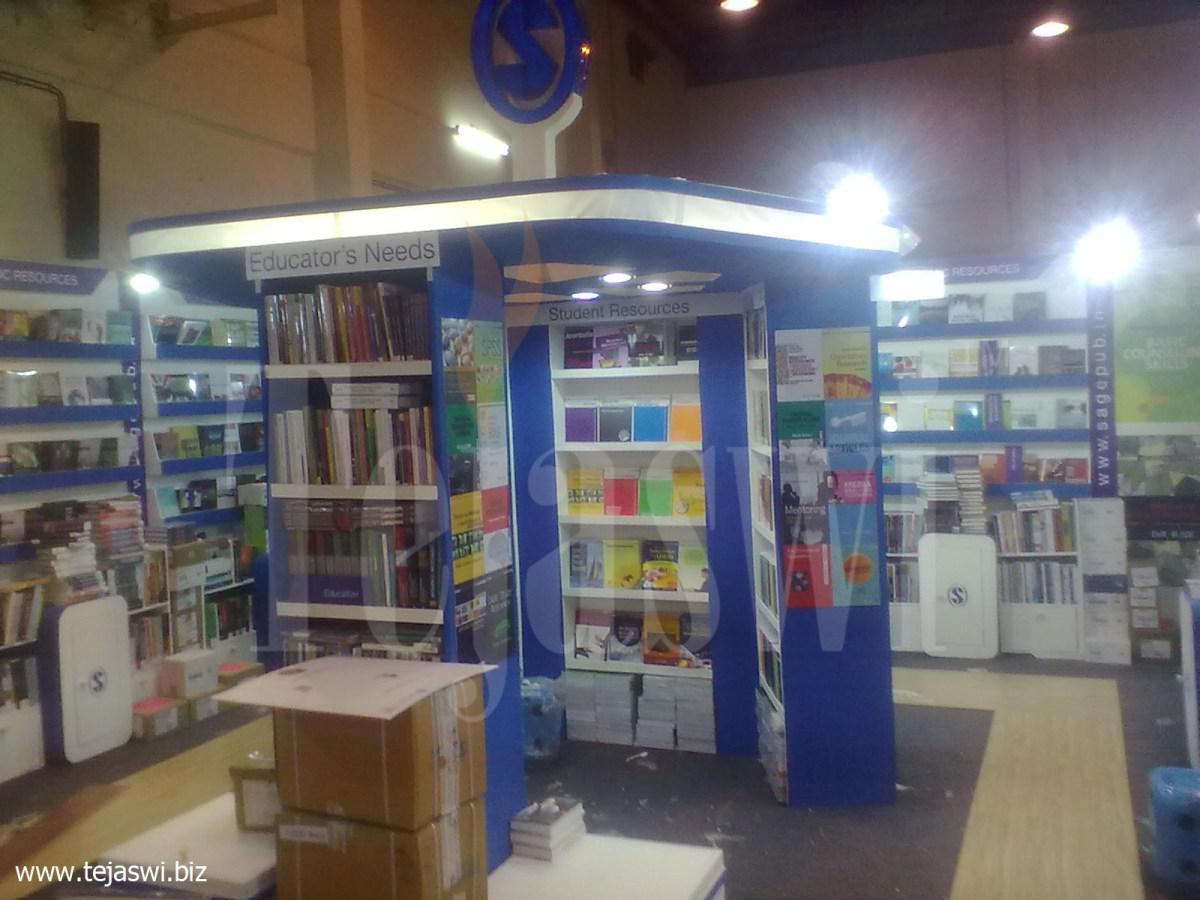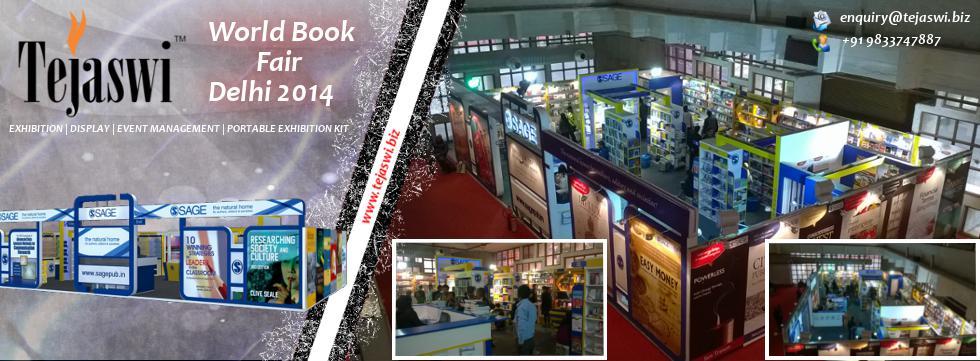The first image is the image on the left, the second image is the image on the right. Considering the images on both sides, is "The left image includes a standing blue display with an S shape in a circle somewhere above it." valid? Answer yes or no. Yes. The first image is the image on the left, the second image is the image on the right. For the images shown, is this caption "In at least one image there is a person sitting on a chair looking at the desk in a kiosk." true? Answer yes or no. No. 